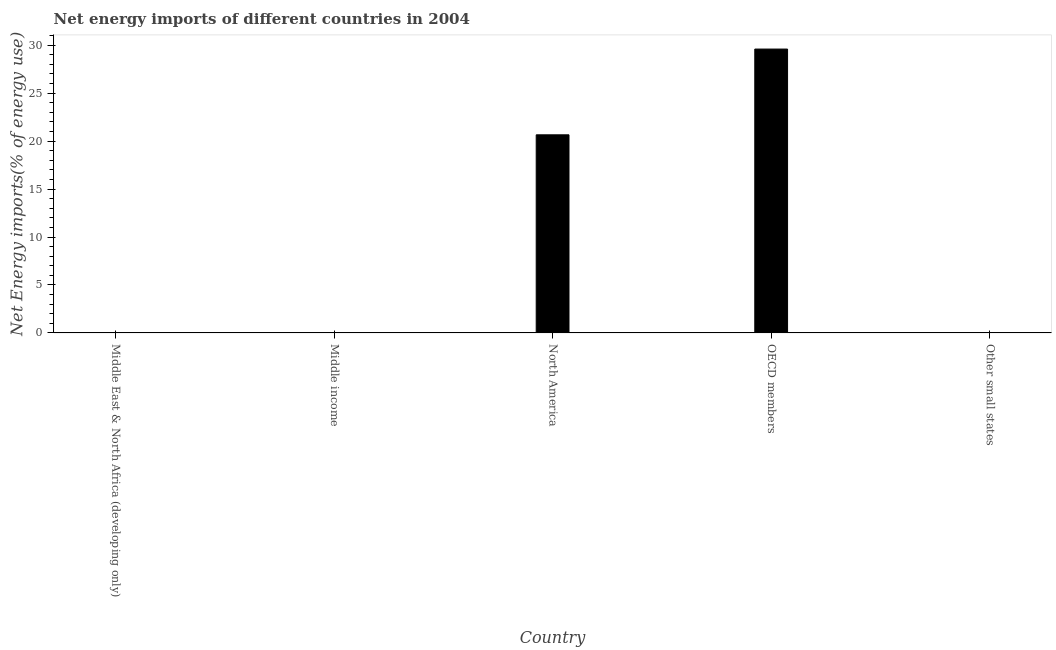Does the graph contain any zero values?
Make the answer very short. Yes. Does the graph contain grids?
Ensure brevity in your answer.  No. What is the title of the graph?
Keep it short and to the point. Net energy imports of different countries in 2004. What is the label or title of the X-axis?
Offer a terse response. Country. What is the label or title of the Y-axis?
Offer a terse response. Net Energy imports(% of energy use). Across all countries, what is the maximum energy imports?
Offer a terse response. 29.6. In which country was the energy imports maximum?
Make the answer very short. OECD members. What is the sum of the energy imports?
Keep it short and to the point. 50.25. What is the average energy imports per country?
Your answer should be very brief. 10.05. What is the median energy imports?
Offer a terse response. 0. In how many countries, is the energy imports greater than 18 %?
Offer a very short reply. 2. Is the sum of the energy imports in North America and OECD members greater than the maximum energy imports across all countries?
Offer a very short reply. Yes. What is the difference between the highest and the lowest energy imports?
Keep it short and to the point. 29.6. In how many countries, is the energy imports greater than the average energy imports taken over all countries?
Make the answer very short. 2. Are all the bars in the graph horizontal?
Your answer should be very brief. No. How many countries are there in the graph?
Offer a very short reply. 5. What is the Net Energy imports(% of energy use) in Middle income?
Make the answer very short. 0. What is the Net Energy imports(% of energy use) in North America?
Offer a very short reply. 20.66. What is the Net Energy imports(% of energy use) of OECD members?
Your answer should be very brief. 29.6. What is the difference between the Net Energy imports(% of energy use) in North America and OECD members?
Provide a short and direct response. -8.94. What is the ratio of the Net Energy imports(% of energy use) in North America to that in OECD members?
Provide a succinct answer. 0.7. 